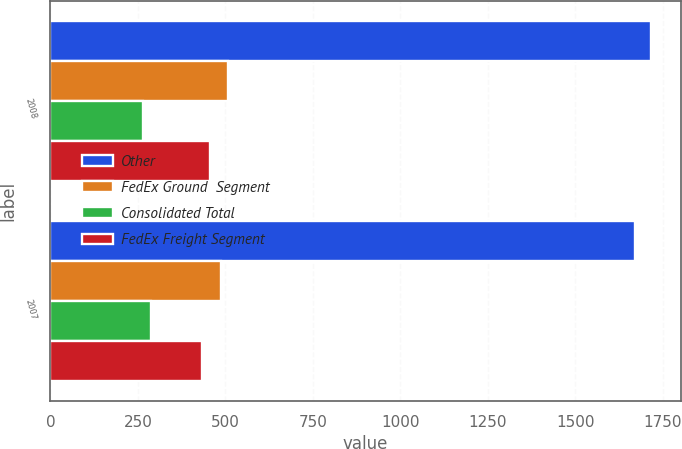Convert chart. <chart><loc_0><loc_0><loc_500><loc_500><stacked_bar_chart><ecel><fcel>2008<fcel>2007<nl><fcel>Other<fcel>1716<fcel>1672<nl><fcel>FedEx Ground  Segment<fcel>509<fcel>489<nl><fcel>Consolidated Total<fcel>266<fcel>287<nl><fcel>FedEx Freight Segment<fcel>455<fcel>432<nl></chart> 